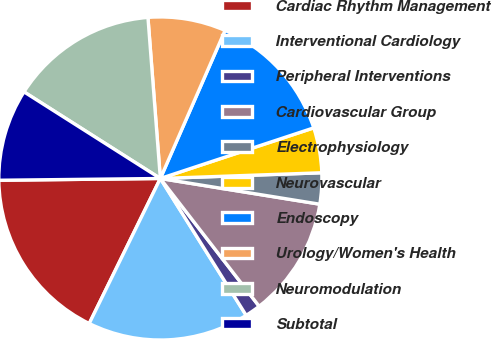Convert chart to OTSL. <chart><loc_0><loc_0><loc_500><loc_500><pie_chart><fcel>Cardiac Rhythm Management<fcel>Interventional Cardiology<fcel>Peripheral Interventions<fcel>Cardiovascular Group<fcel>Electrophysiology<fcel>Neurovascular<fcel>Endoscopy<fcel>Urology/Women's Health<fcel>Neuromodulation<fcel>Subtotal<nl><fcel>17.57%<fcel>16.17%<fcel>1.56%<fcel>11.98%<fcel>3.11%<fcel>4.51%<fcel>13.37%<fcel>7.78%<fcel>14.77%<fcel>9.18%<nl></chart> 